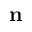<formula> <loc_0><loc_0><loc_500><loc_500>n</formula> 